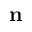<formula> <loc_0><loc_0><loc_500><loc_500>n</formula> 